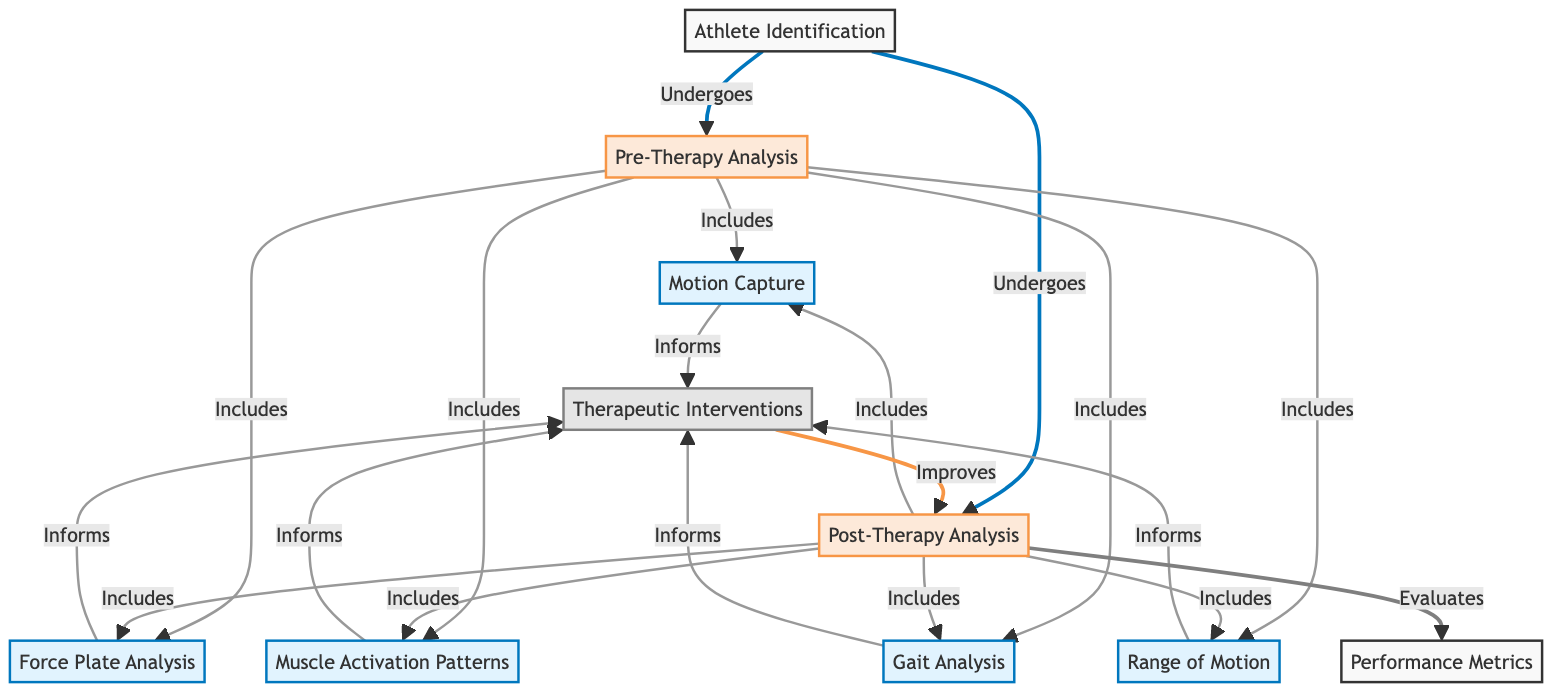What is the first step after athlete identification? The diagram indicates that the first step after athlete identification is pre-therapy analysis, which is shown to directly follow after the identification node.
Answer: Pre-Therapy Analysis How many analysis processes are included in pre-therapy? The diagram lists five specific processes that fall under the pre-therapy analysis, namely motion capture, force plate analysis, muscle activation patterns, gait analysis, and range of motion. Therefore, the total is five processes.
Answer: 5 Which analysis is evaluated after the post-therapy analysis? The diagram indicates that post-therapy analysis evaluates performance metrics, which is the node that directly follows the analysis step.
Answer: Performance Metrics What informs the therapeutic interventions? The diagram specifies that the combined results from motion capture, force plate analysis, muscle activation patterns, gait analysis, and range of motion are what inform therapeutic interventions, as these nodes lead to the intervention node.
Answer: Motion Capture, Force Plate Analysis, Muscle Activation Patterns, Gait Analysis, Range of Motion What happens to the post-therapy analysis after therapeutic interventions? According to the diagram, post-therapy analysis improves following the implementation of therapeutic interventions, indicating a positive impact from the interventions on the analysis results.
Answer: Improves How does post-therapy analysis relate to pre-therapy analysis? The relationship between post-therapy analysis and pre-therapy analysis is that post-therapy analysis assesses performance metrics, which can be inferred to be a measure of improvement based on pre-therapy conditions. This implies a comparative analysis between pre- and post-conditions.
Answer: Evaluates Performance Metrics 